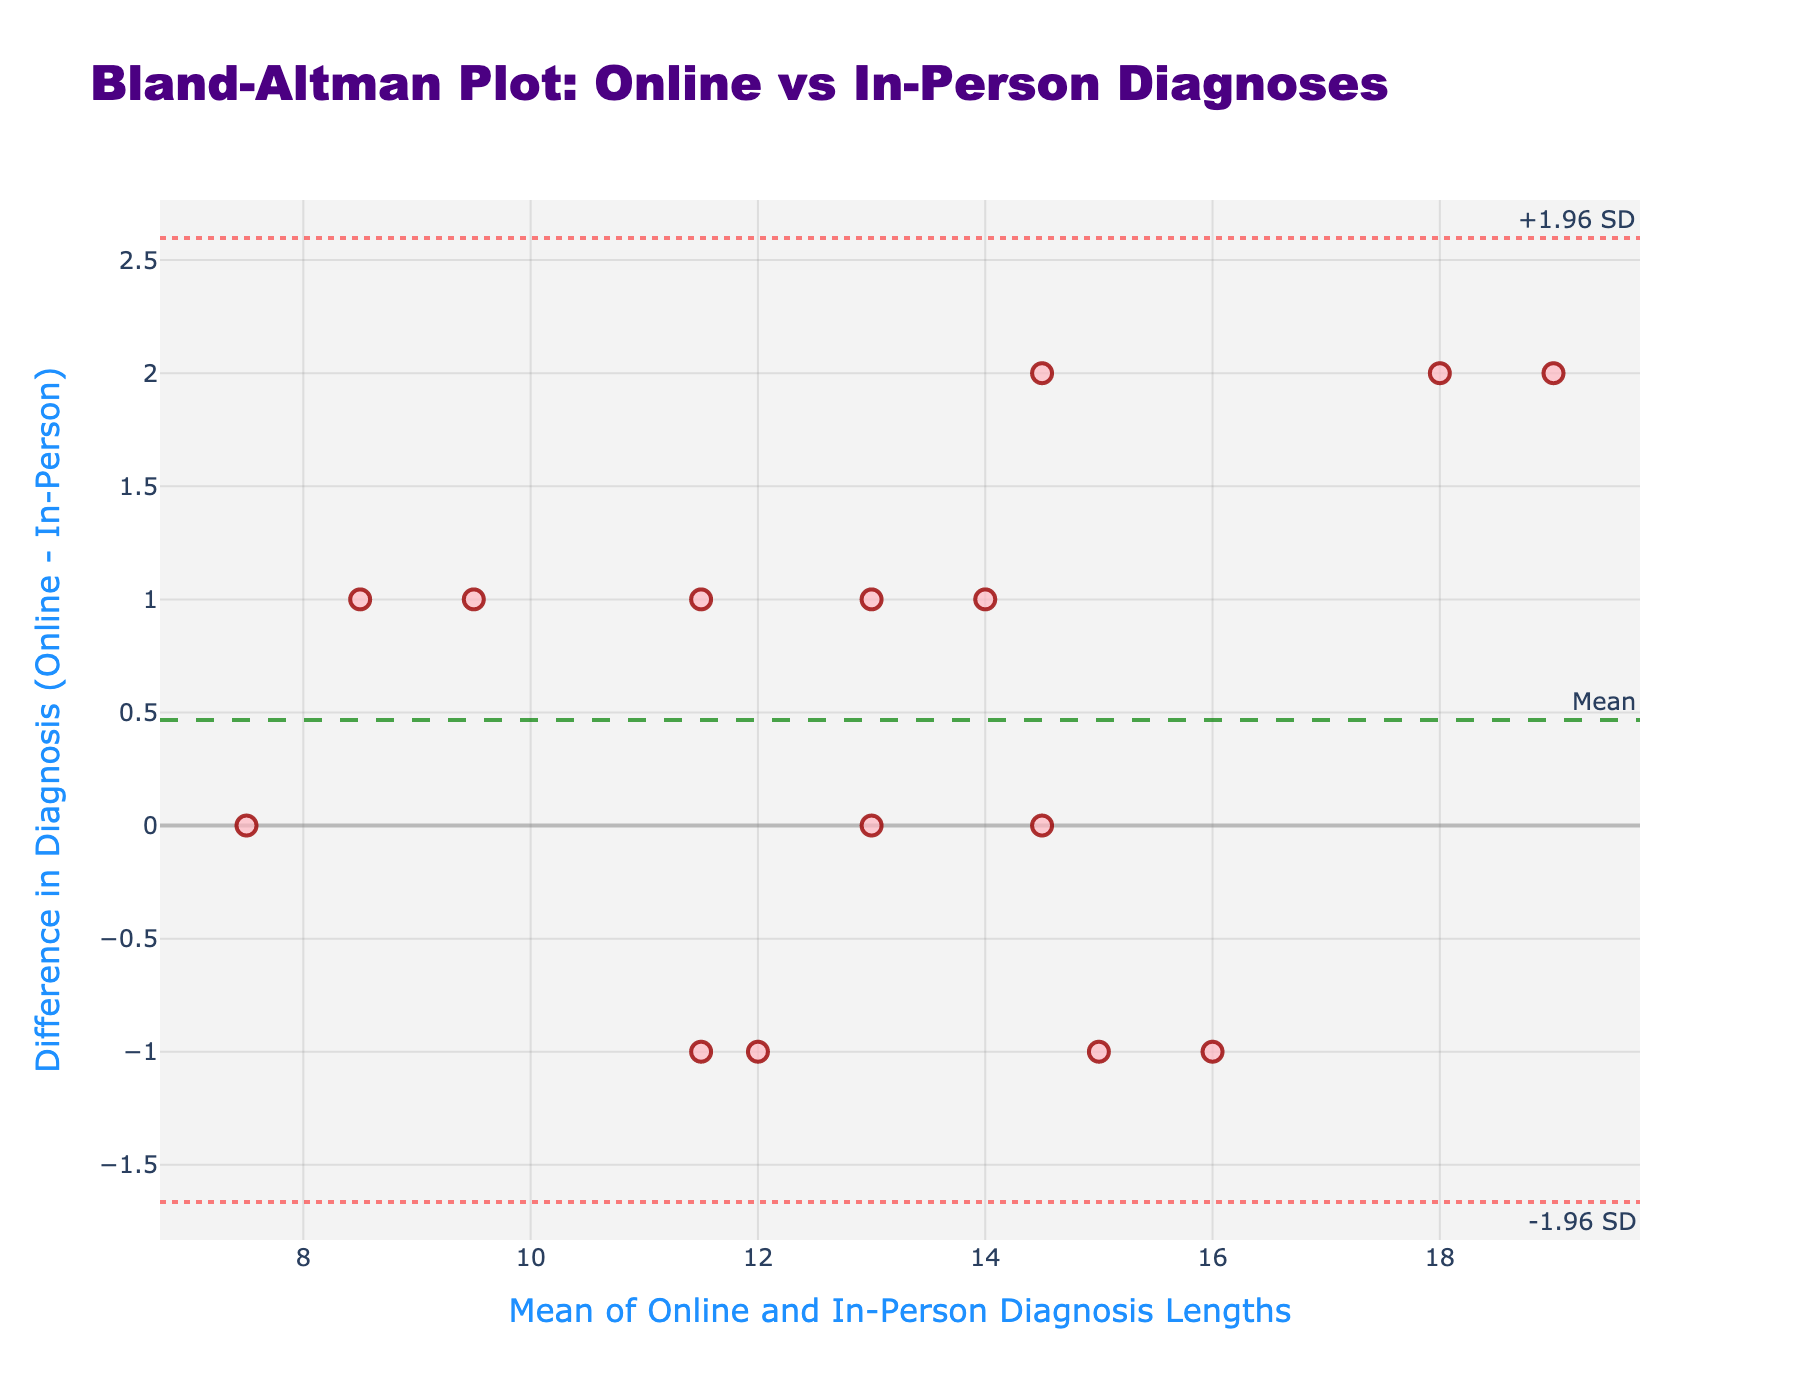What's the title of the figure? The title is located at the top part of the figure. The text describes the main concept of the plot.
Answer: Bland-Altman Plot: Online vs In-Person Diagnoses What is represented on the x-axis? The x-axis title is seen just below the horizontal axis and describes what the axis measures. It refers to the mean of online and in-person diagnosis lengths.
Answer: Mean of Online and In-Person Diagnosis Lengths What does the y-axis represent? The y-axis title is located just beside the vertical axis and indicates that it measures the difference between online and in-person diagnoses.
Answer: Difference in Diagnosis (Online - In-Person) What color are the data points on the plot? The data points are marked using a specific color that can easily be identified visually. They appear in a light pink shade.
Answer: Light pink What is the mean difference between online and in-person diagnoses? A dashed line is used to denote the mean difference, which is annotated on the plot. Look for the corresponding annotation and line.
Answer: 0.33 What are the upper and lower limits of agreement? The upper and lower limits of agreement are represented by dotted lines and corresponding annotations. Look for lines labeled with "+1.96 SD" and "-1.96 SD".
Answer: +1.96 SD is 1.93 and -1.96 SD is -1.27 What is the difference between the diagnoses for 'Urinary Tract Infection' and 'Kidney Stones'? Locate the data point for 'Urinary Tract Infection vs Kidney Stones' from the hover text and read the y-axis value of this specific point to identify the difference.
Answer: 2 Which diagnosis pair has the largest positive difference? Identify the data point with the highest y-axis value. The hover text for this point will provide the specific diagnosis pair.
Answer: Urinary Tract Infection vs Kidney Stones How many data points lie outside the limits of agreement? Visually count the number of points that fall above the upper limit (+1.96 SD) or below the lower limit (-1.96 SD).
Answer: 0 What is the range of the mean values for the diagnosis lengths? Determine the lowest and highest values on the x-axis where the data points are located. This range covers the mean values for diagnosis lengths.
Answer: 10.0 to 15.5 